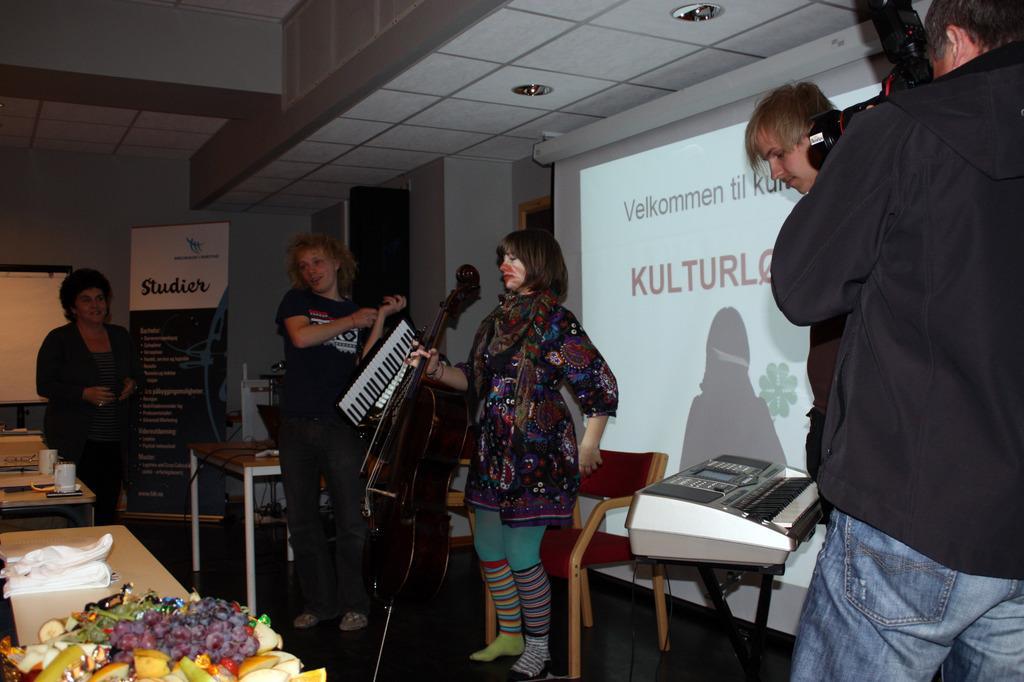How would you summarize this image in a sentence or two? There is a women standing and holding a violin in her hand and there is another person beside her is holding a piano and there is a person in the right corner is holding a camera in his hand there is a table in front of them which has few objects placed on it. 